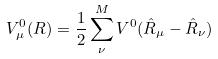<formula> <loc_0><loc_0><loc_500><loc_500>V ^ { 0 } _ { \mu } ( R ) & = \frac { 1 } { 2 } \sum _ { \nu } ^ { M } V ^ { 0 } ( \hat { R } _ { \mu } - \hat { R } _ { \nu } )</formula> 